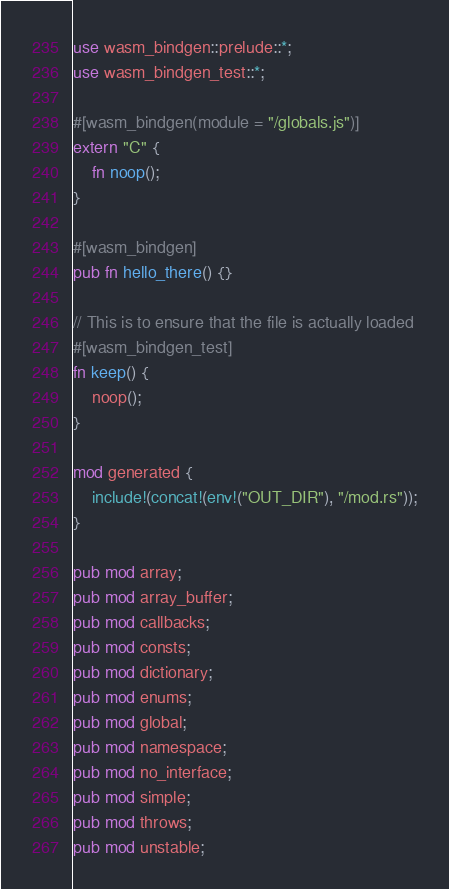Convert code to text. <code><loc_0><loc_0><loc_500><loc_500><_Rust_>use wasm_bindgen::prelude::*;
use wasm_bindgen_test::*;

#[wasm_bindgen(module = "/globals.js")]
extern "C" {
    fn noop();
}

#[wasm_bindgen]
pub fn hello_there() {}

// This is to ensure that the file is actually loaded
#[wasm_bindgen_test]
fn keep() {
    noop();
}

mod generated {
    include!(concat!(env!("OUT_DIR"), "/mod.rs"));
}

pub mod array;
pub mod array_buffer;
pub mod callbacks;
pub mod consts;
pub mod dictionary;
pub mod enums;
pub mod global;
pub mod namespace;
pub mod no_interface;
pub mod simple;
pub mod throws;
pub mod unstable;
</code> 